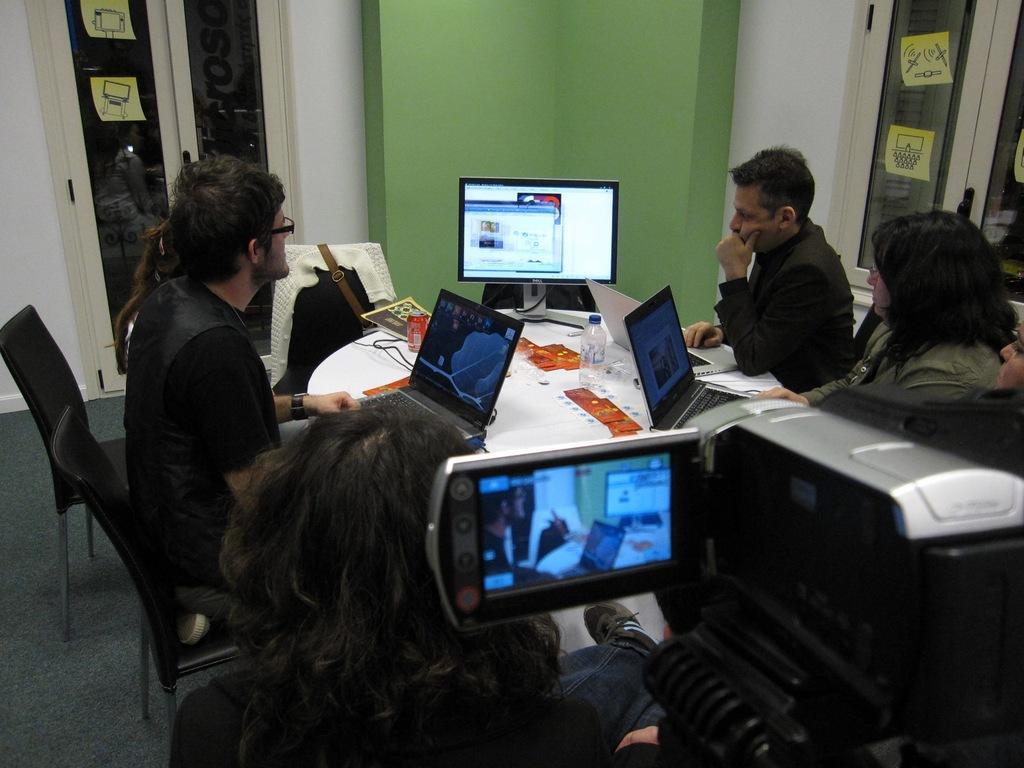How would you summarize this image in a sentence or two? In this image we can see there are people sitting on the chairs and working on a laptop. And we can see the system, papers and a few objects on the table. At the back we can see the stickers attached to the glass. And there are windows, door and wall. 